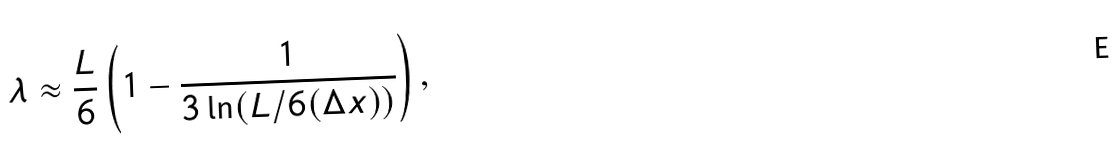Convert formula to latex. <formula><loc_0><loc_0><loc_500><loc_500>\lambda \approx \frac { L } { 6 } \left ( 1 - \frac { 1 } { 3 \ln ( L / 6 ( \Delta x ) ) } \right ) ,</formula> 